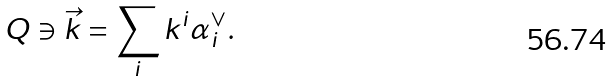Convert formula to latex. <formula><loc_0><loc_0><loc_500><loc_500>Q \ni \vec { k } = \sum _ { i } k ^ { i } \alpha _ { i } ^ { \vee } .</formula> 